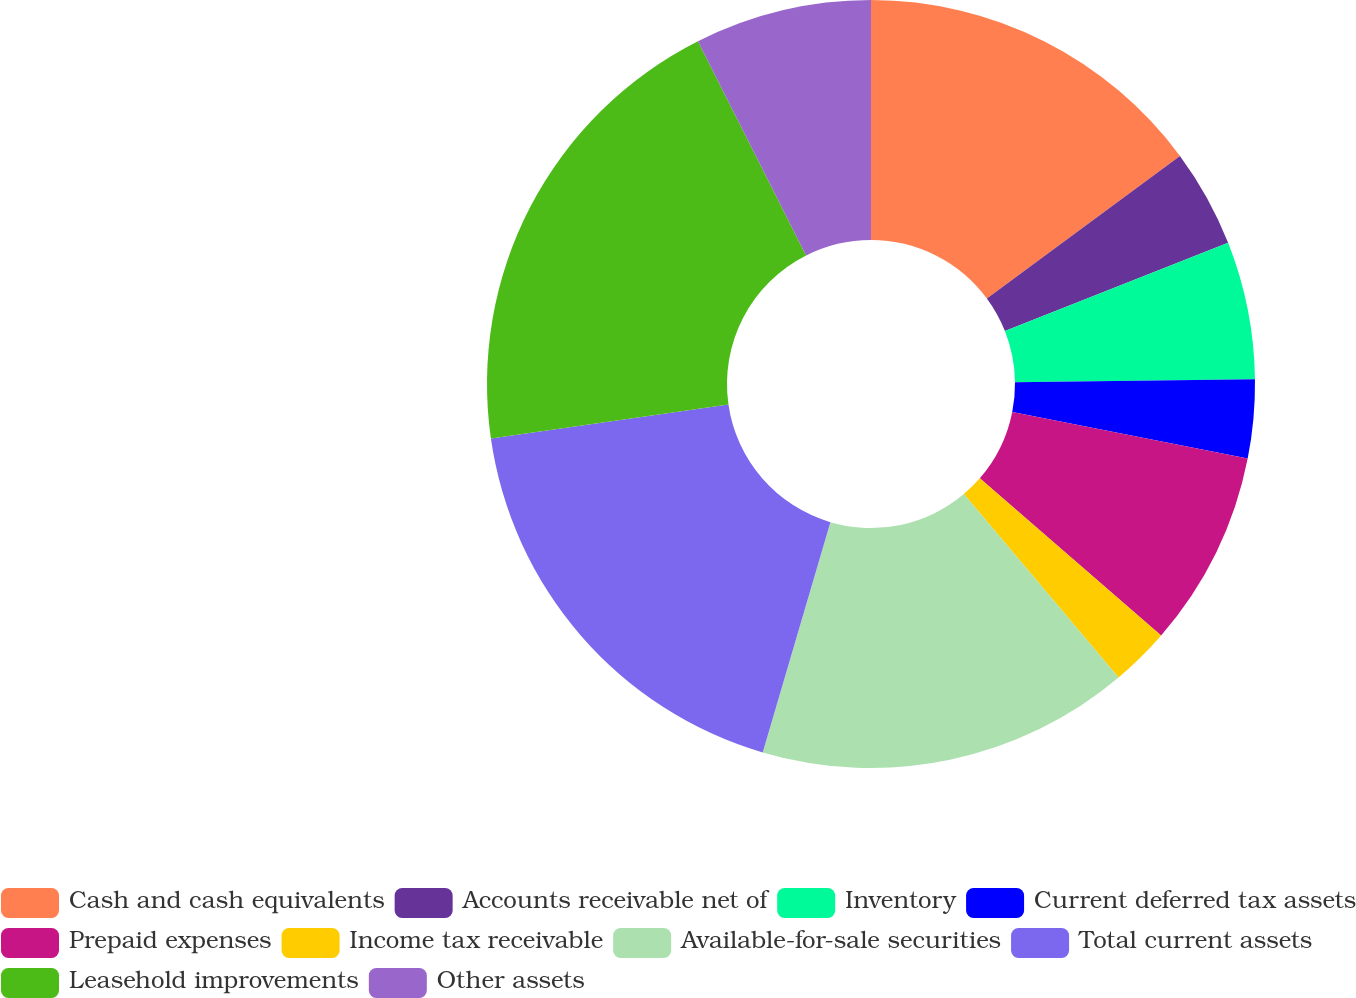Convert chart. <chart><loc_0><loc_0><loc_500><loc_500><pie_chart><fcel>Cash and cash equivalents<fcel>Accounts receivable net of<fcel>Inventory<fcel>Current deferred tax assets<fcel>Prepaid expenses<fcel>Income tax receivable<fcel>Available-for-sale securities<fcel>Total current assets<fcel>Leasehold improvements<fcel>Other assets<nl><fcel>14.88%<fcel>4.13%<fcel>5.79%<fcel>3.31%<fcel>8.26%<fcel>2.48%<fcel>15.7%<fcel>18.18%<fcel>19.83%<fcel>7.44%<nl></chart> 